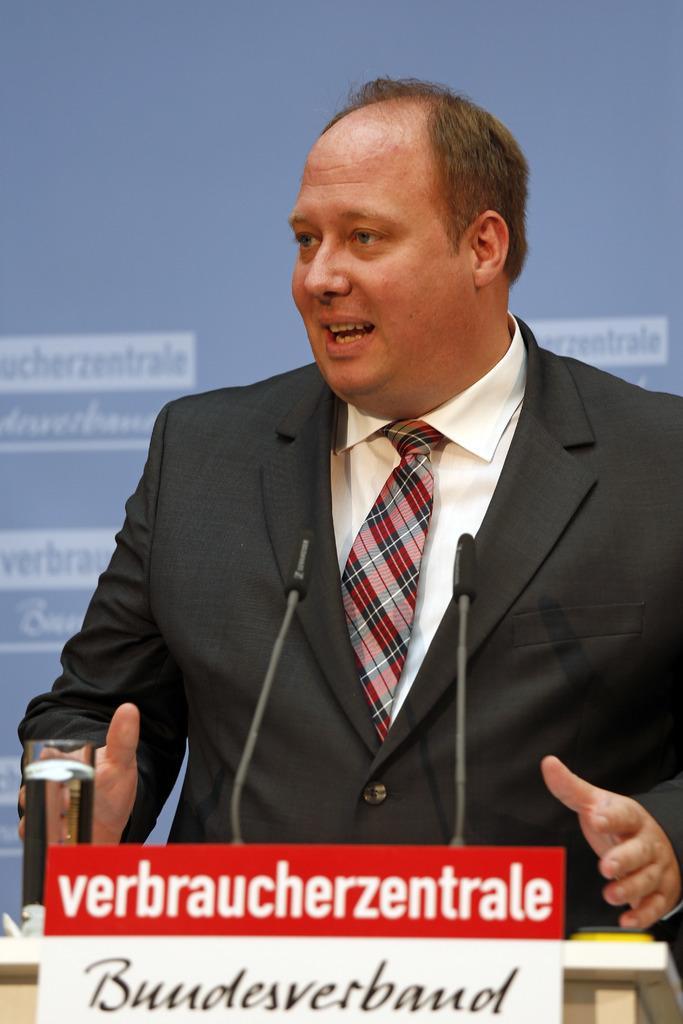In one or two sentences, can you explain what this image depicts? In this image there is a person standing and looking to the left side of the image, in front of him there is a table with some objects and mics on it, there is a board with some text, behind the person there is a banner with some text on it. 